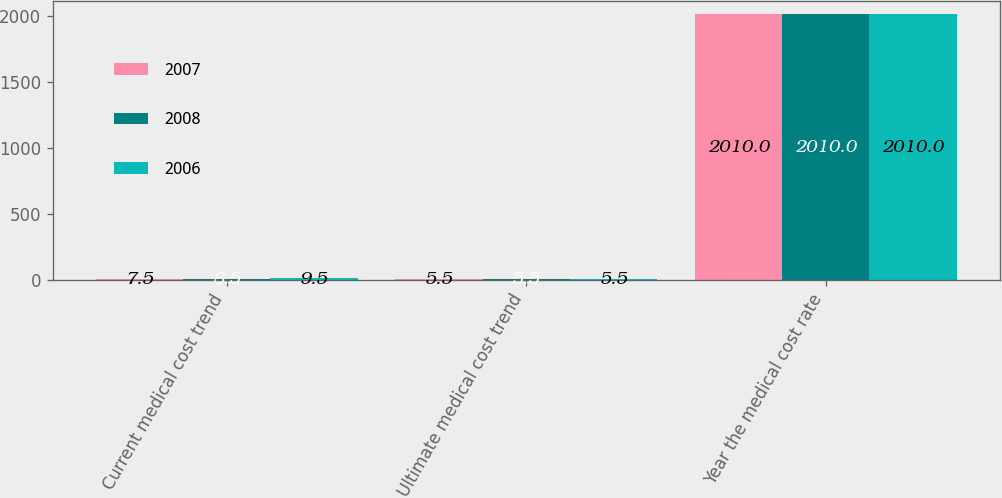<chart> <loc_0><loc_0><loc_500><loc_500><stacked_bar_chart><ecel><fcel>Current medical cost trend<fcel>Ultimate medical cost trend<fcel>Year the medical cost rate<nl><fcel>2007<fcel>7.5<fcel>5.5<fcel>2010<nl><fcel>2008<fcel>8.5<fcel>5.5<fcel>2010<nl><fcel>2006<fcel>9.5<fcel>5.5<fcel>2010<nl></chart> 